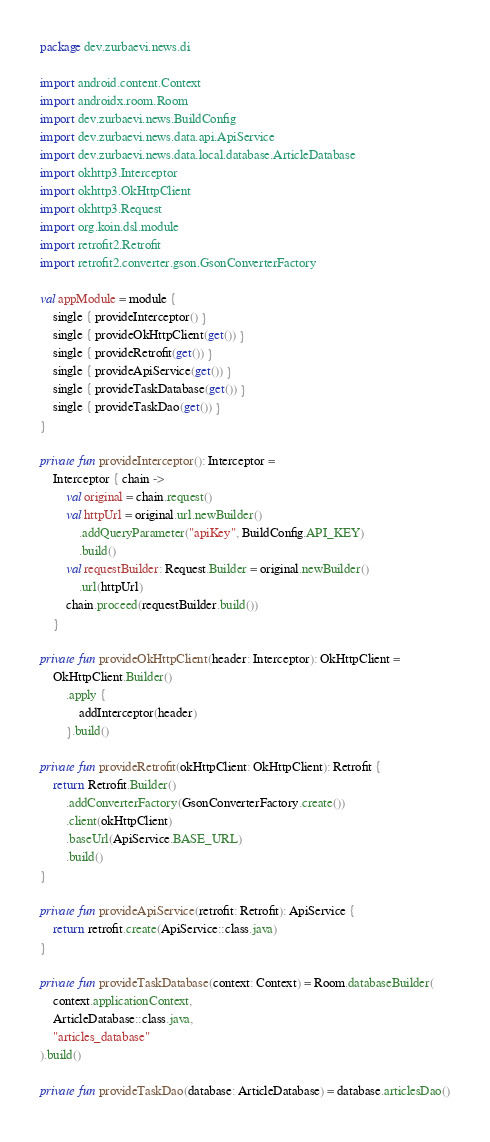Convert code to text. <code><loc_0><loc_0><loc_500><loc_500><_Kotlin_>package dev.zurbaevi.news.di

import android.content.Context
import androidx.room.Room
import dev.zurbaevi.news.BuildConfig
import dev.zurbaevi.news.data.api.ApiService
import dev.zurbaevi.news.data.local.database.ArticleDatabase
import okhttp3.Interceptor
import okhttp3.OkHttpClient
import okhttp3.Request
import org.koin.dsl.module
import retrofit2.Retrofit
import retrofit2.converter.gson.GsonConverterFactory

val appModule = module {
    single { provideInterceptor() }
    single { provideOkHttpClient(get()) }
    single { provideRetrofit(get()) }
    single { provideApiService(get()) }
    single { provideTaskDatabase(get()) }
    single { provideTaskDao(get()) }
}

private fun provideInterceptor(): Interceptor =
    Interceptor { chain ->
        val original = chain.request()
        val httpUrl = original.url.newBuilder()
            .addQueryParameter("apiKey", BuildConfig.API_KEY)
            .build()
        val requestBuilder: Request.Builder = original.newBuilder()
            .url(httpUrl)
        chain.proceed(requestBuilder.build())
    }

private fun provideOkHttpClient(header: Interceptor): OkHttpClient =
    OkHttpClient.Builder()
        .apply {
            addInterceptor(header)
        }.build()

private fun provideRetrofit(okHttpClient: OkHttpClient): Retrofit {
    return Retrofit.Builder()
        .addConverterFactory(GsonConverterFactory.create())
        .client(okHttpClient)
        .baseUrl(ApiService.BASE_URL)
        .build()
}

private fun provideApiService(retrofit: Retrofit): ApiService {
    return retrofit.create(ApiService::class.java)
}

private fun provideTaskDatabase(context: Context) = Room.databaseBuilder(
    context.applicationContext,
    ArticleDatabase::class.java,
    "articles_database"
).build()

private fun provideTaskDao(database: ArticleDatabase) = database.articlesDao()</code> 